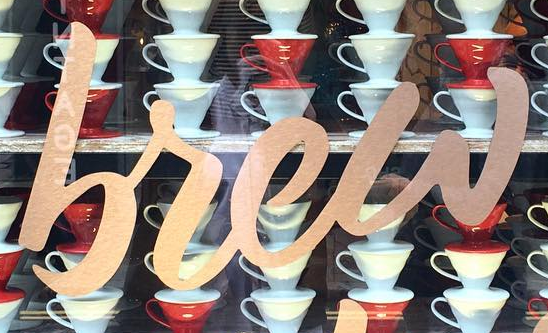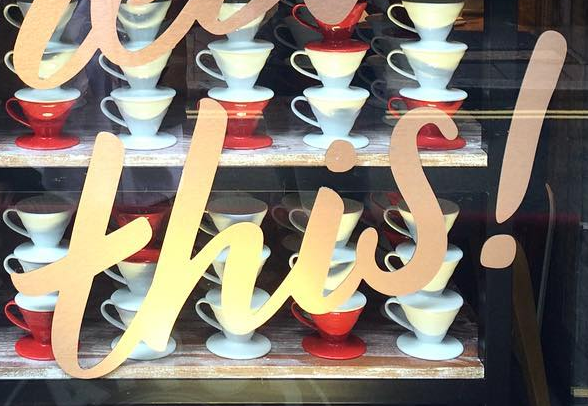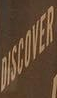Read the text content from these images in order, separated by a semicolon. brew; this!; DISCOVER 